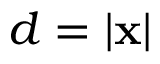<formula> <loc_0><loc_0><loc_500><loc_500>d = | x |</formula> 